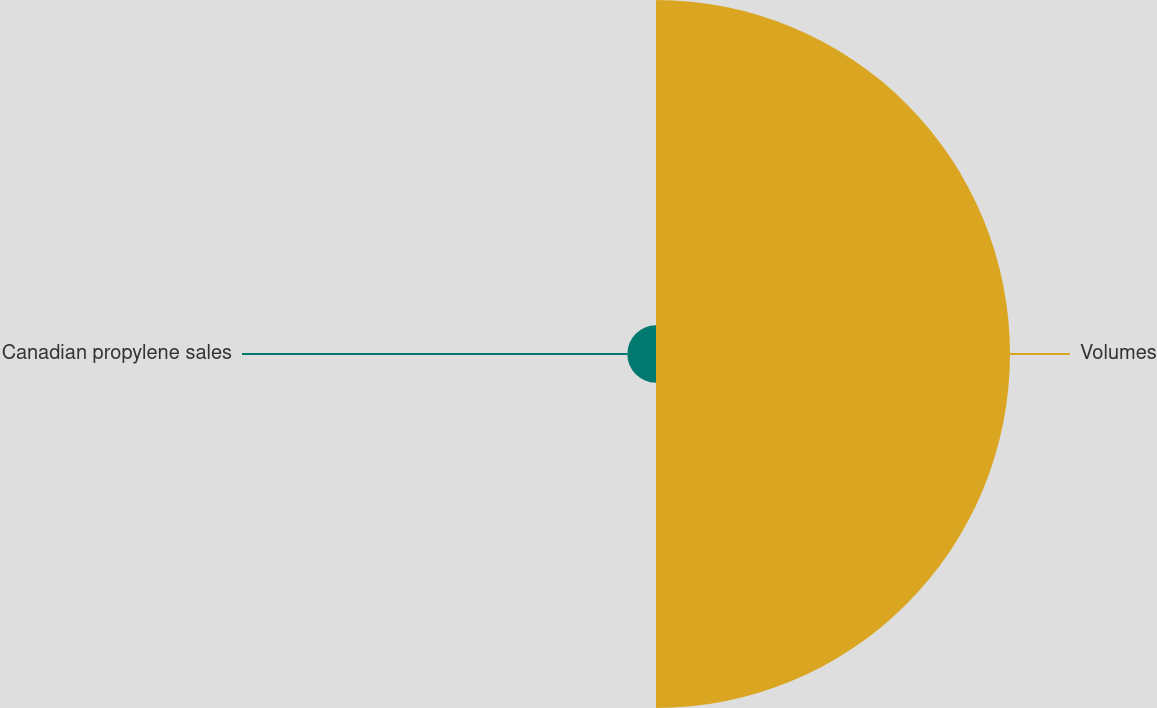Convert chart to OTSL. <chart><loc_0><loc_0><loc_500><loc_500><pie_chart><fcel>Volumes<fcel>Canadian propylene sales<nl><fcel>92.5%<fcel>7.5%<nl></chart> 